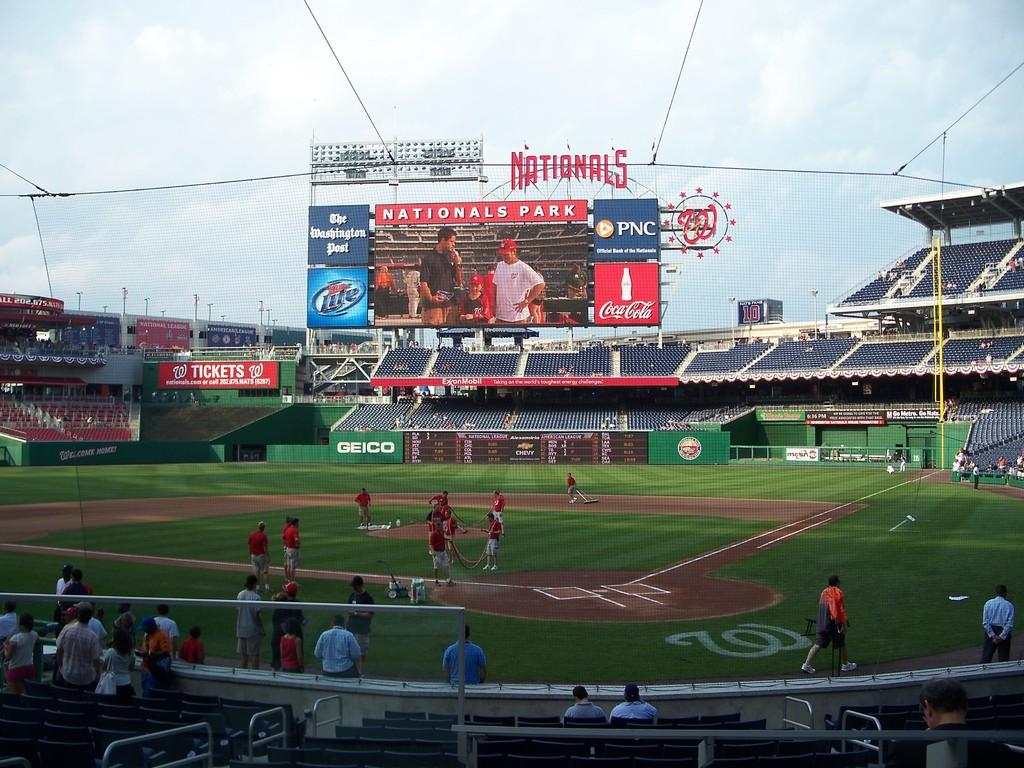Where is the game being played?
Your answer should be very brief. Nationals park. What is the name of this ball park?
Offer a terse response. Nationals park. 